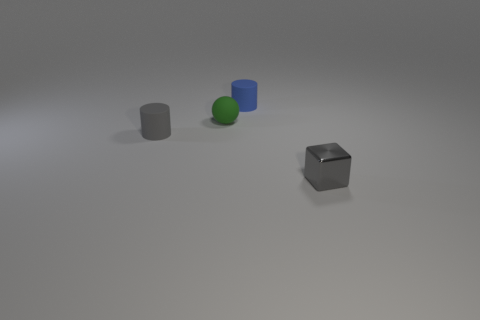Subtract all brown cubes. Subtract all cyan balls. How many cubes are left? 1 Add 3 cyan matte cubes. How many objects exist? 7 Subtract all balls. How many objects are left? 3 Subtract 1 green spheres. How many objects are left? 3 Subtract all tiny gray shiny blocks. Subtract all tiny green metal spheres. How many objects are left? 3 Add 1 green rubber spheres. How many green rubber spheres are left? 2 Add 2 big gray matte things. How many big gray matte things exist? 2 